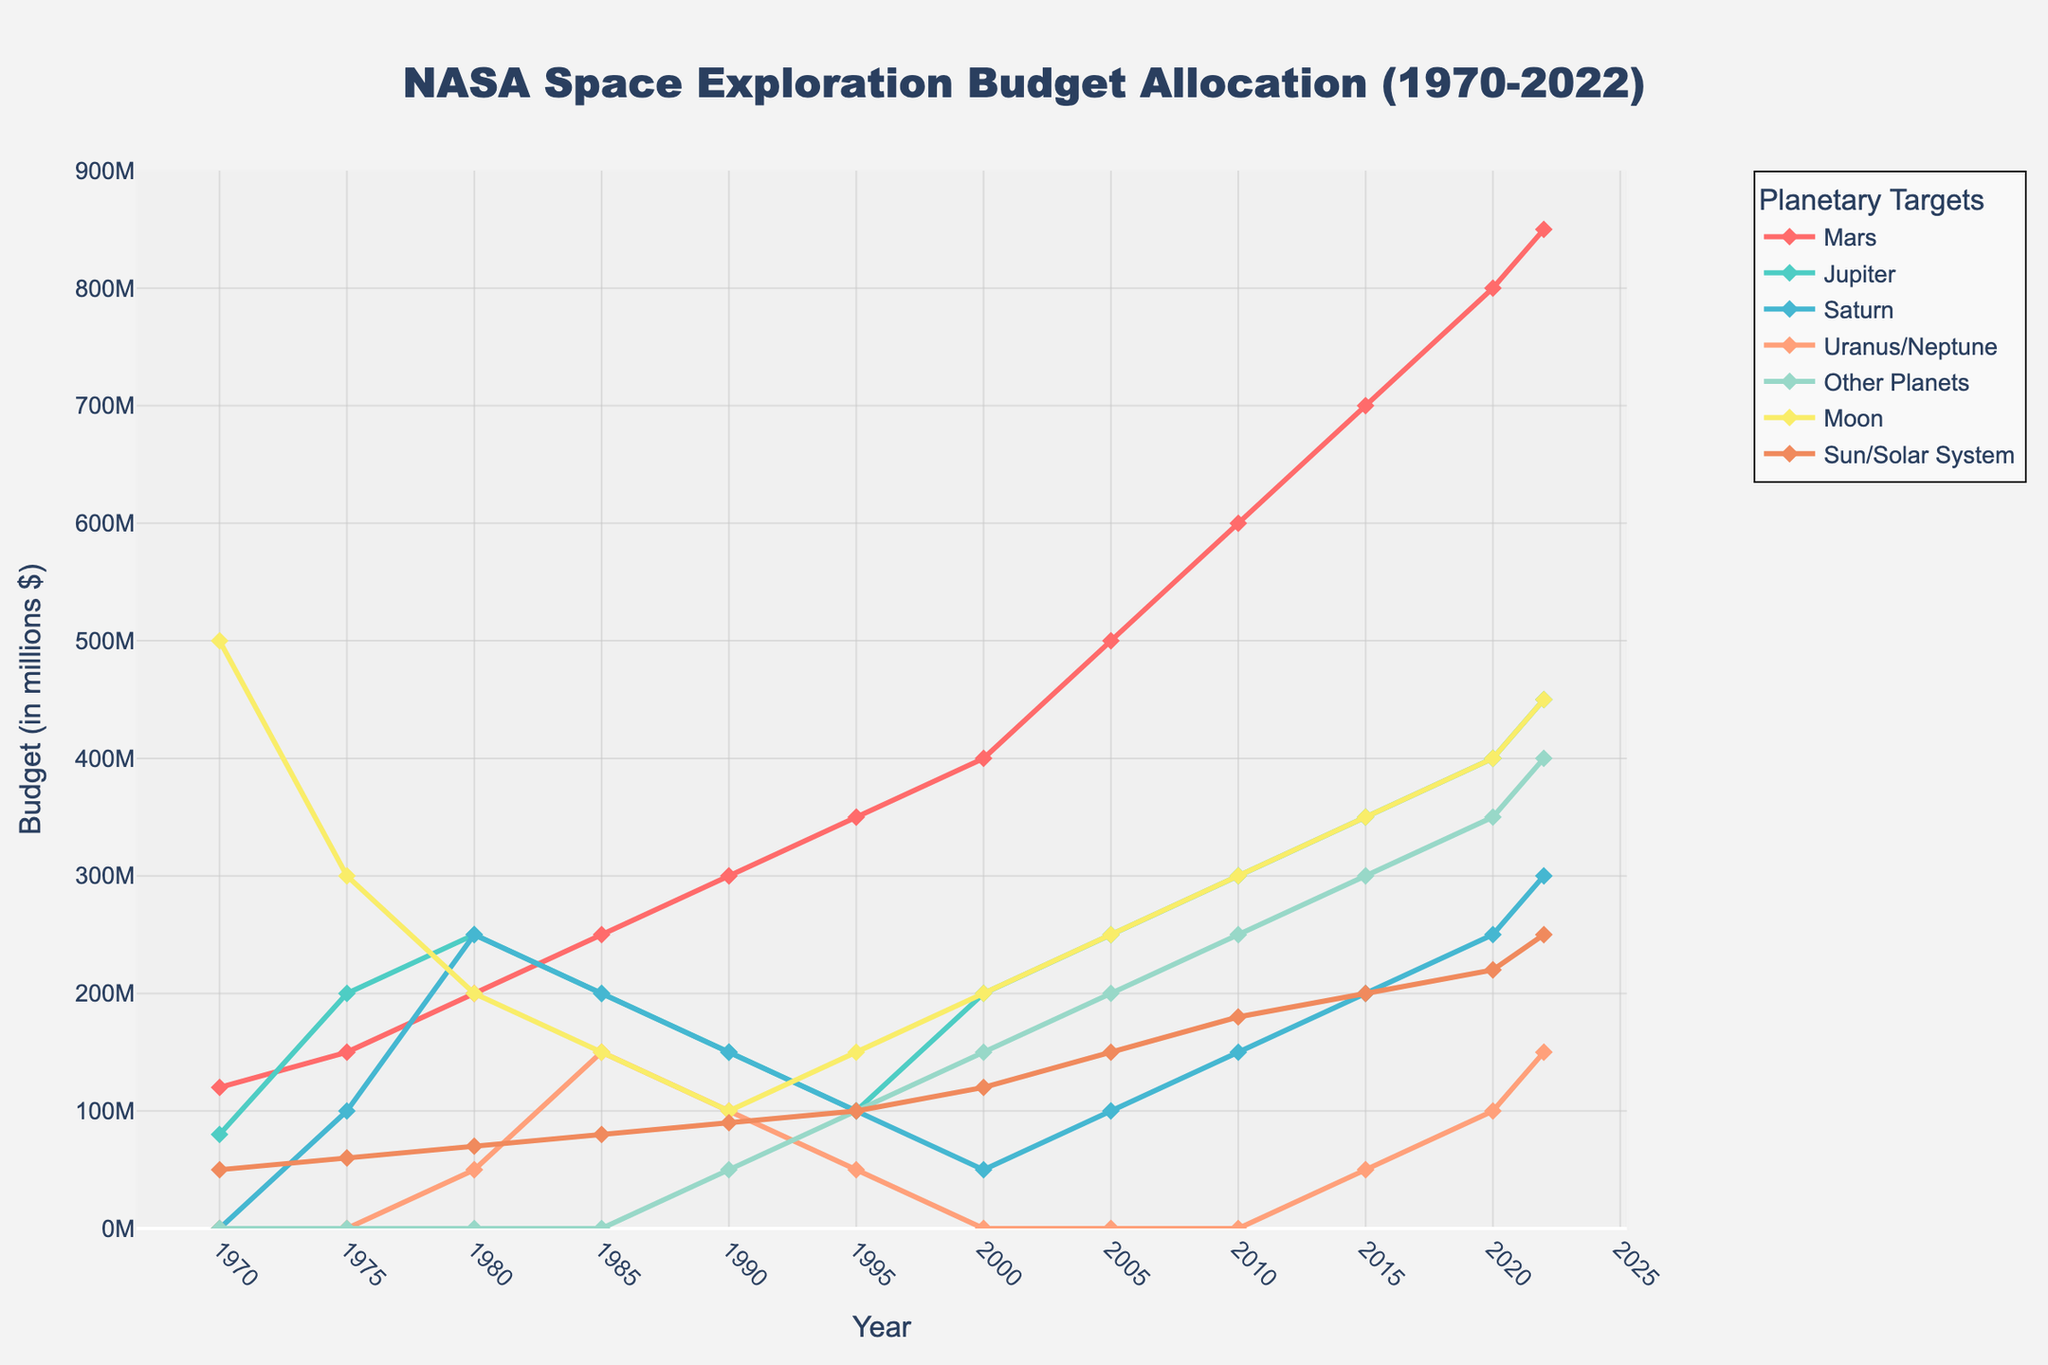What was the budget allocation for Mars in 2022? To find the budget for Mars in 2022, look at the value at the intersection of the "Mars" column and the year 2022.
Answer: 850 million How did the budget for Jupiter in 1975 compare to the budget for Saturn in the same year? Refer to the year 1975 and compare the budget values for Jupiter and Saturn. Jupiter's budget was 200 million, while Saturn's was 100 million.
Answer: Jupiter's budget was 100 million higher than Saturn's Which planetary target saw the most significant increase in budget allocation from 1970 to 2022? Compare the values from 1970 to 2022 for all categories. Mars had an increase from 120 million to 850 million, which is the highest increase.
Answer: Mars What is the sum of the budget allocations for Uranus/Neptune and Other Planets in 2022? Add the values from the year 2022 for Uranus/Neptune (150 million) and Other Planets (400 million).
Answer: 550 million What can you deduce about the budget trends for the Moon and Sun/Solar System from 1970 to 2022? Observe the trend of the budget allocation over the years. Both the Moon and Sun/Solar System show a general upward trend in their budget allocations.
Answer: Increasing trends Which year had the highest combined budget allocation for Mars and Moon? Add the budget allocations for Mars and the Moon for each year and determine the maximum value. The year 2022 had Mars (850 million) + Moon (450 million) = 1300 million.
Answer: 2022 How does the 1980 budget allocation for Other Planets compare to that for Uranus/Neptune? In 1980, the budget for Other Planets was 0 million, and for Uranus/Neptune, it was 50 million.
Answer: Uranus/Neptune had a higher budget by 50 million Between the years 2000 and 2022, which planetary target had the most consistent budget increase? Examine the budgets from 2000 to 2022 for each target. Mars has a consistently increasing budget each year.
Answer: Mars What is the average budget allocation for Saturn over the entire period? Sum all the budget values for Saturn and divide by the number of years. (0 + 100 + 250 + 200 + 150 + 100 + 50 + 100 + 150 + 200 + 250 + 300) / 12 = 1500 / 12.
Answer: 125 million Which planetary target had the highest budget allocation in 1970? Look at the budget allocations for all planetary targets in the year 1970. The Moon had the highest budget.
Answer: Moon 